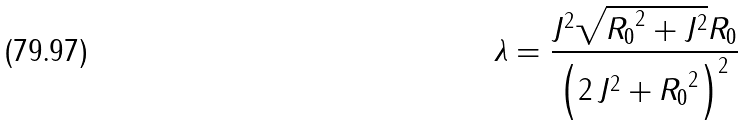<formula> <loc_0><loc_0><loc_500><loc_500>\lambda = { \frac { { J } ^ { 2 } \sqrt { { R _ { 0 } } ^ { 2 } + { J } ^ { 2 } } R _ { 0 } } { \left ( 2 \, { J } ^ { 2 } + { R _ { 0 } } ^ { 2 } \right ) ^ { 2 } } }</formula> 